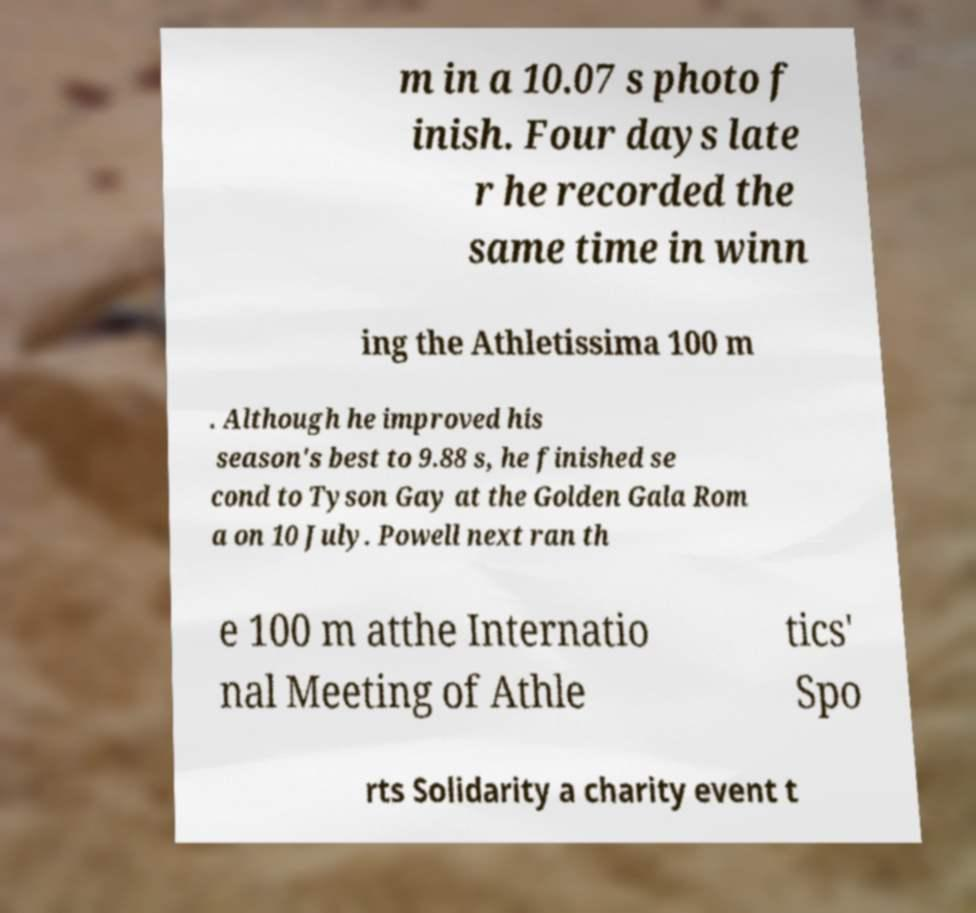Please read and relay the text visible in this image. What does it say? m in a 10.07 s photo f inish. Four days late r he recorded the same time in winn ing the Athletissima 100 m . Although he improved his season's best to 9.88 s, he finished se cond to Tyson Gay at the Golden Gala Rom a on 10 July. Powell next ran th e 100 m atthe Internatio nal Meeting of Athle tics' Spo rts Solidarity a charity event t 